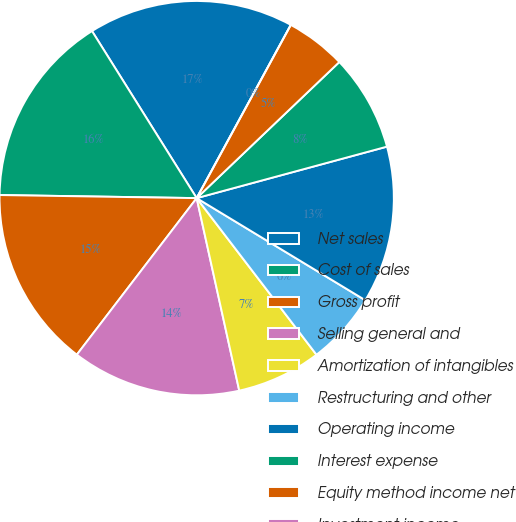Convert chart to OTSL. <chart><loc_0><loc_0><loc_500><loc_500><pie_chart><fcel>Net sales<fcel>Cost of sales<fcel>Gross profit<fcel>Selling general and<fcel>Amortization of intangibles<fcel>Restructuring and other<fcel>Operating income<fcel>Interest expense<fcel>Equity method income net<fcel>Investment income<nl><fcel>16.83%<fcel>15.84%<fcel>14.85%<fcel>13.86%<fcel>6.93%<fcel>5.94%<fcel>12.87%<fcel>7.92%<fcel>4.95%<fcel>0.0%<nl></chart> 